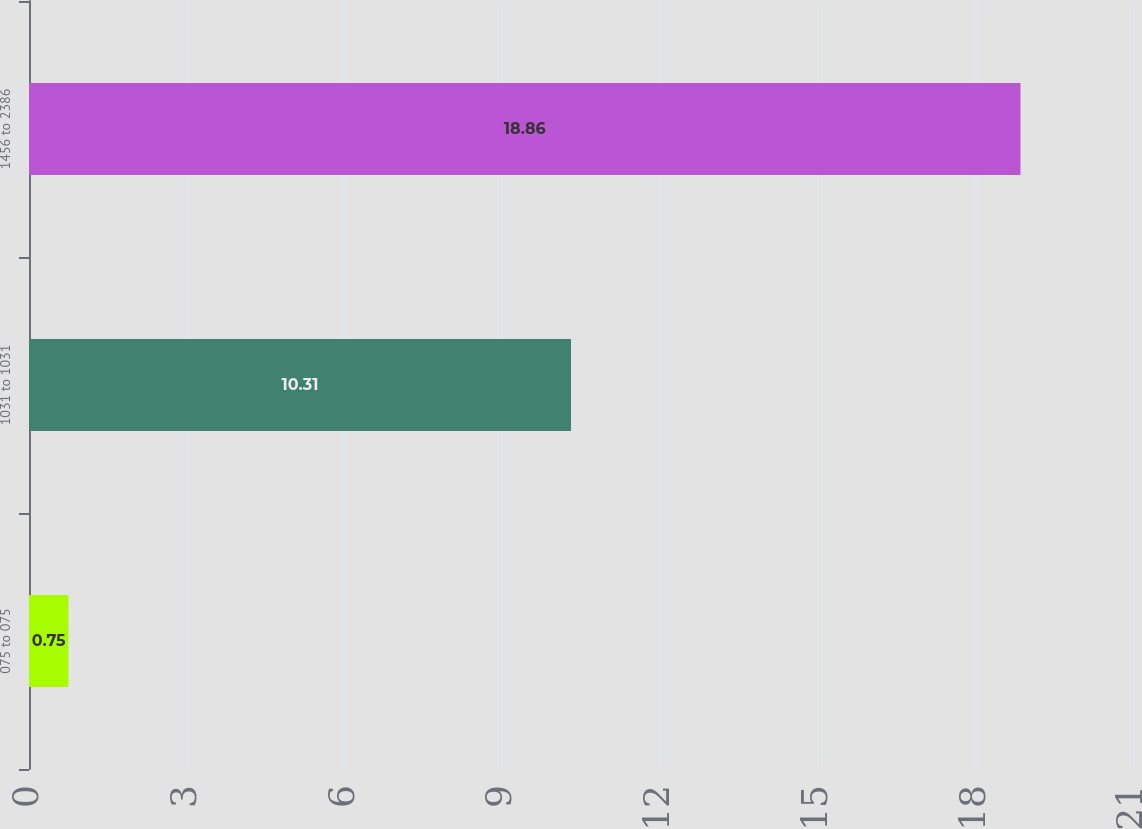Convert chart to OTSL. <chart><loc_0><loc_0><loc_500><loc_500><bar_chart><fcel>075 to 075<fcel>1031 to 1031<fcel>1456 to 2386<nl><fcel>0.75<fcel>10.31<fcel>18.86<nl></chart> 